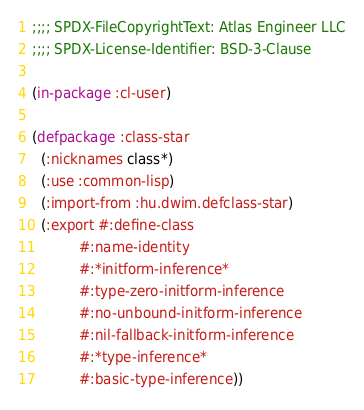Convert code to text. <code><loc_0><loc_0><loc_500><loc_500><_Lisp_>;;;; SPDX-FileCopyrightText: Atlas Engineer LLC
;;;; SPDX-License-Identifier: BSD-3-Clause

(in-package :cl-user)

(defpackage :class-star
  (:nicknames class*)
  (:use :common-lisp)
  (:import-from :hu.dwim.defclass-star)
  (:export #:define-class
           #:name-identity
           #:*initform-inference*
           #:type-zero-initform-inference
           #:no-unbound-initform-inference
           #:nil-fallback-initform-inference
           #:*type-inference*
           #:basic-type-inference))
</code> 